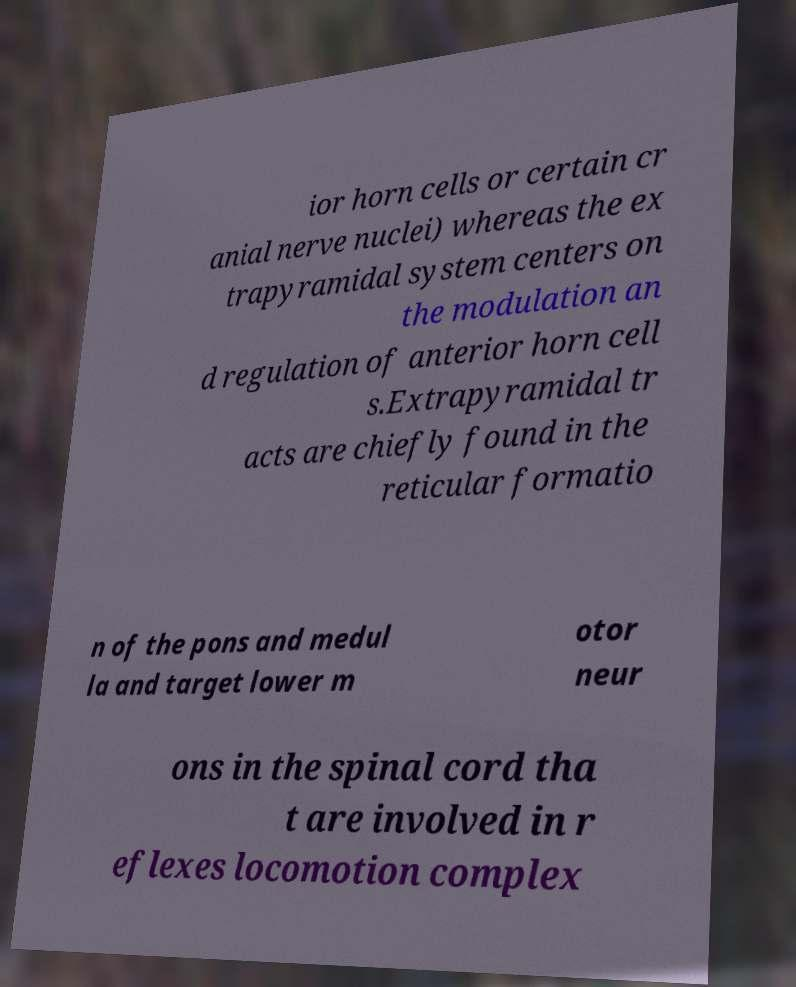What messages or text are displayed in this image? I need them in a readable, typed format. ior horn cells or certain cr anial nerve nuclei) whereas the ex trapyramidal system centers on the modulation an d regulation of anterior horn cell s.Extrapyramidal tr acts are chiefly found in the reticular formatio n of the pons and medul la and target lower m otor neur ons in the spinal cord tha t are involved in r eflexes locomotion complex 